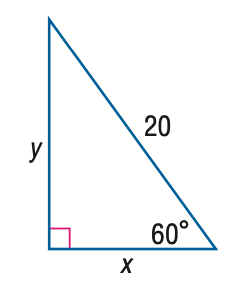Question: Find y.
Choices:
A. 10
B. 10 \sqrt { 2 }
C. 10 \sqrt { 3 }
D. 20
Answer with the letter. Answer: C Question: Find x.
Choices:
A. 10
B. 10 \sqrt { 2 }
C. 10 \sqrt { 3 }
D. 20
Answer with the letter. Answer: A 